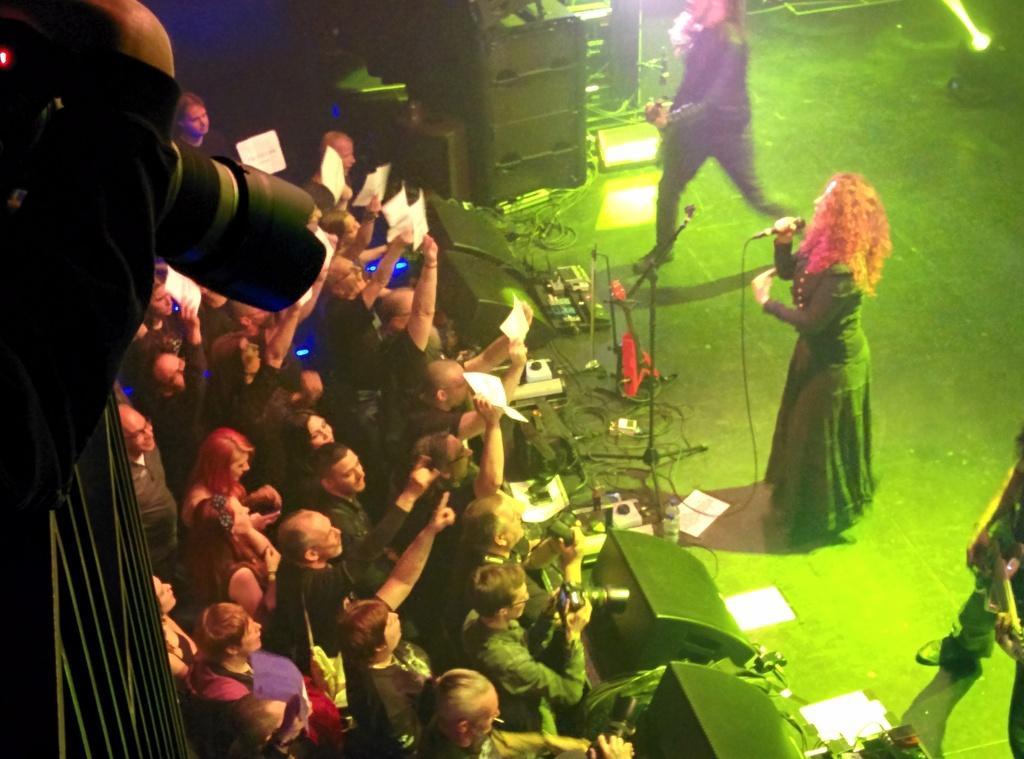Describe this image in one or two sentences. In this image there is a woman holding a mic, besides the women there are two people standing and playing guitars, in front of them there are speakers, switches, cables and some other objects on the floor, in front of them there are a few people standing, holding cameras and papers in their hands, on the left side of the image there is a camera in a person's hand, below the hand there is a metal rod fence, on the right side of the image there is a focus light. 